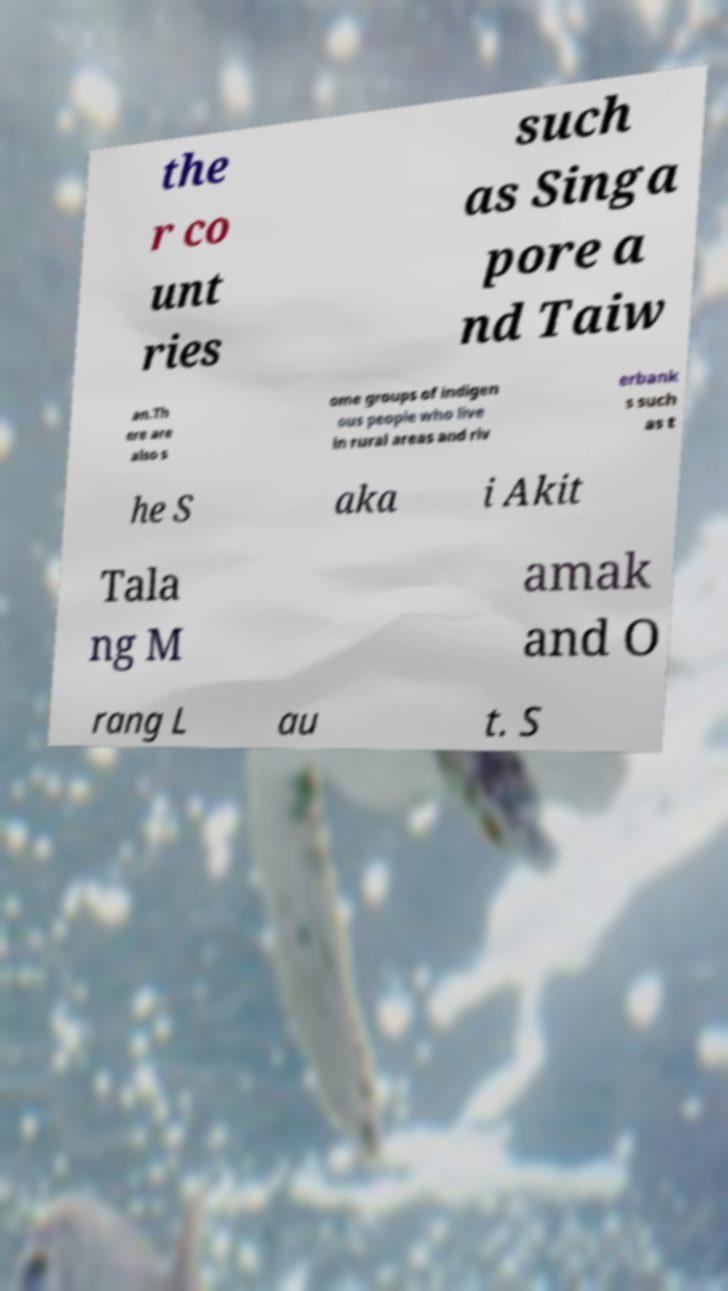Could you extract and type out the text from this image? the r co unt ries such as Singa pore a nd Taiw an.Th ere are also s ome groups of indigen ous people who live in rural areas and riv erbank s such as t he S aka i Akit Tala ng M amak and O rang L au t. S 